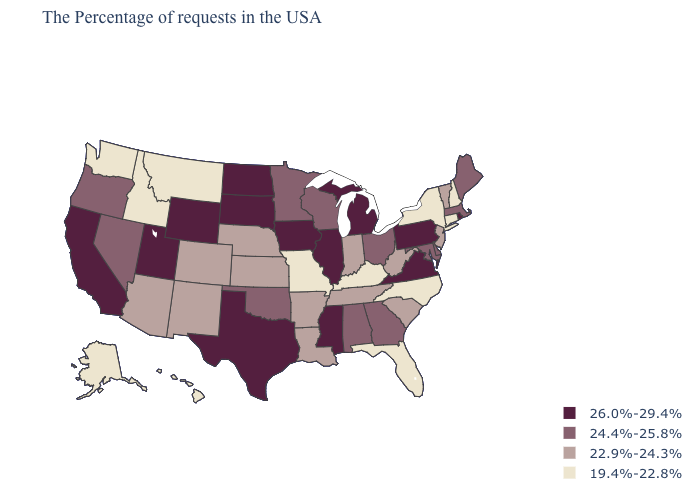What is the highest value in the Northeast ?
Short answer required. 26.0%-29.4%. What is the value of Minnesota?
Keep it brief. 24.4%-25.8%. What is the highest value in the USA?
Quick response, please. 26.0%-29.4%. Among the states that border Missouri , which have the lowest value?
Quick response, please. Kentucky. Does Hawaii have the same value as North Carolina?
Be succinct. Yes. Name the states that have a value in the range 26.0%-29.4%?
Concise answer only. Rhode Island, Pennsylvania, Virginia, Michigan, Illinois, Mississippi, Iowa, Texas, South Dakota, North Dakota, Wyoming, Utah, California. Does North Dakota have the highest value in the USA?
Answer briefly. Yes. Name the states that have a value in the range 19.4%-22.8%?
Be succinct. New Hampshire, Connecticut, New York, North Carolina, Florida, Kentucky, Missouri, Montana, Idaho, Washington, Alaska, Hawaii. Does Kentucky have the same value as Oregon?
Give a very brief answer. No. What is the value of Hawaii?
Write a very short answer. 19.4%-22.8%. What is the highest value in the USA?
Answer briefly. 26.0%-29.4%. How many symbols are there in the legend?
Keep it brief. 4. Among the states that border Iowa , which have the lowest value?
Give a very brief answer. Missouri. Does the map have missing data?
Quick response, please. No. Does Hawaii have the highest value in the USA?
Quick response, please. No. 